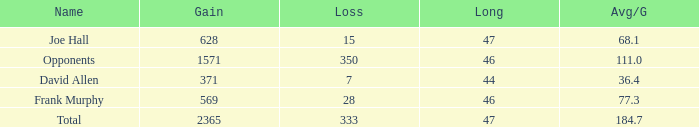How much Loss has a Gain smaller than 1571, and a Long smaller than 47, and an Avg/G of 36.4? 1.0. 